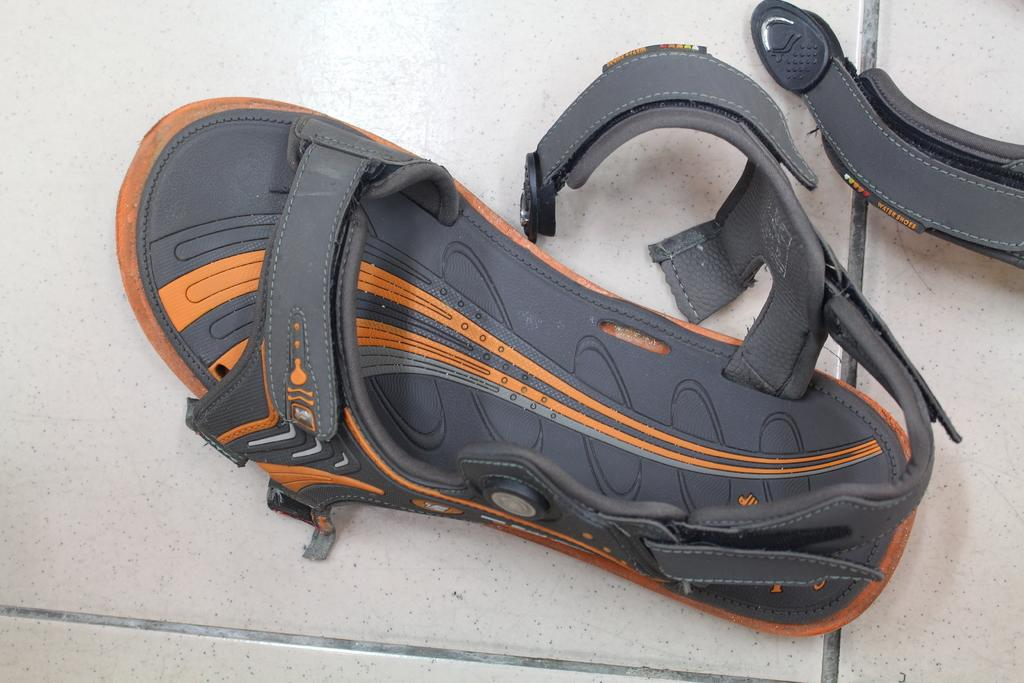What type of clothing item is on the floor in the image? There is footwear on the floor in the image. What accessory is visible in the image? There is a belt visible in the image. What type of mask is being worn by the person in the image? There is no person wearing a mask in the image; only footwear and a belt are visible. What time of day is depicted in the image? The time of day cannot be determined from the image, as there are no specific clues or indicators present. 